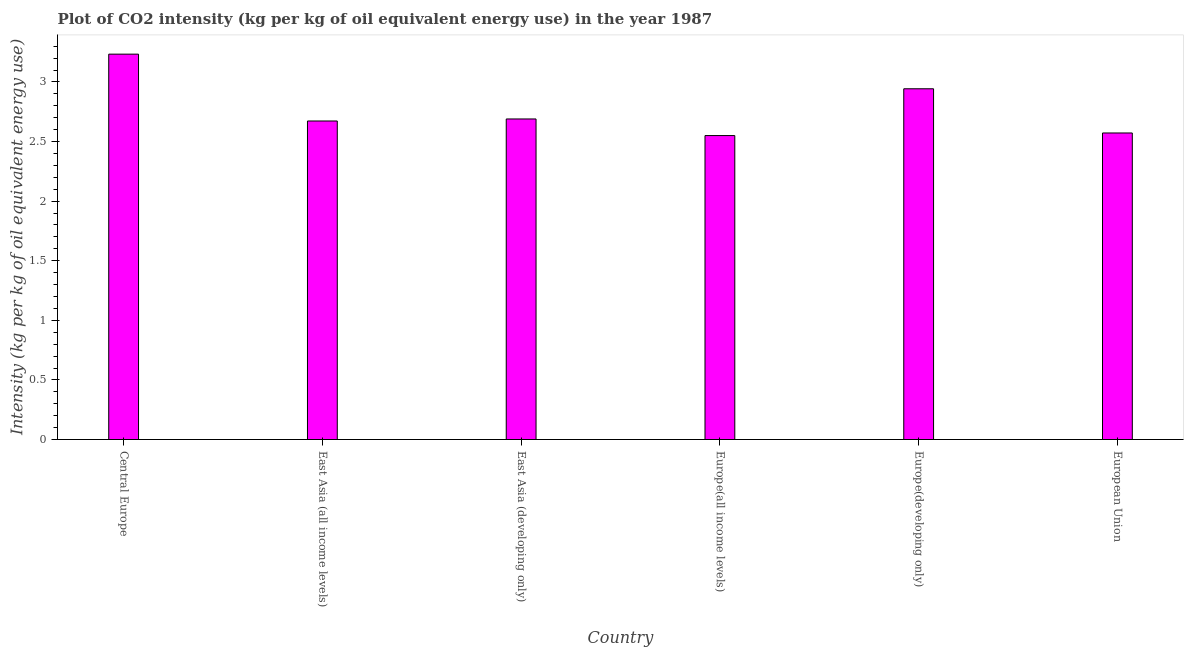Does the graph contain any zero values?
Keep it short and to the point. No. What is the title of the graph?
Offer a very short reply. Plot of CO2 intensity (kg per kg of oil equivalent energy use) in the year 1987. What is the label or title of the X-axis?
Your answer should be very brief. Country. What is the label or title of the Y-axis?
Provide a short and direct response. Intensity (kg per kg of oil equivalent energy use). What is the co2 intensity in East Asia (all income levels)?
Keep it short and to the point. 2.67. Across all countries, what is the maximum co2 intensity?
Make the answer very short. 3.23. Across all countries, what is the minimum co2 intensity?
Your answer should be very brief. 2.55. In which country was the co2 intensity maximum?
Offer a terse response. Central Europe. In which country was the co2 intensity minimum?
Your response must be concise. Europe(all income levels). What is the sum of the co2 intensity?
Provide a succinct answer. 16.66. What is the difference between the co2 intensity in East Asia (all income levels) and Europe(all income levels)?
Keep it short and to the point. 0.12. What is the average co2 intensity per country?
Provide a succinct answer. 2.78. What is the median co2 intensity?
Keep it short and to the point. 2.68. What is the ratio of the co2 intensity in Central Europe to that in Europe(developing only)?
Your response must be concise. 1.1. Is the co2 intensity in East Asia (all income levels) less than that in Europe(all income levels)?
Provide a short and direct response. No. Is the difference between the co2 intensity in East Asia (all income levels) and Europe(all income levels) greater than the difference between any two countries?
Keep it short and to the point. No. What is the difference between the highest and the second highest co2 intensity?
Offer a terse response. 0.29. Is the sum of the co2 intensity in Europe(developing only) and European Union greater than the maximum co2 intensity across all countries?
Your answer should be compact. Yes. What is the difference between the highest and the lowest co2 intensity?
Offer a very short reply. 0.68. What is the Intensity (kg per kg of oil equivalent energy use) of Central Europe?
Provide a short and direct response. 3.23. What is the Intensity (kg per kg of oil equivalent energy use) of East Asia (all income levels)?
Your answer should be very brief. 2.67. What is the Intensity (kg per kg of oil equivalent energy use) of East Asia (developing only)?
Offer a very short reply. 2.69. What is the Intensity (kg per kg of oil equivalent energy use) of Europe(all income levels)?
Provide a succinct answer. 2.55. What is the Intensity (kg per kg of oil equivalent energy use) in Europe(developing only)?
Provide a succinct answer. 2.94. What is the Intensity (kg per kg of oil equivalent energy use) in European Union?
Ensure brevity in your answer.  2.57. What is the difference between the Intensity (kg per kg of oil equivalent energy use) in Central Europe and East Asia (all income levels)?
Your answer should be very brief. 0.56. What is the difference between the Intensity (kg per kg of oil equivalent energy use) in Central Europe and East Asia (developing only)?
Your answer should be compact. 0.54. What is the difference between the Intensity (kg per kg of oil equivalent energy use) in Central Europe and Europe(all income levels)?
Offer a terse response. 0.68. What is the difference between the Intensity (kg per kg of oil equivalent energy use) in Central Europe and Europe(developing only)?
Offer a very short reply. 0.29. What is the difference between the Intensity (kg per kg of oil equivalent energy use) in Central Europe and European Union?
Give a very brief answer. 0.66. What is the difference between the Intensity (kg per kg of oil equivalent energy use) in East Asia (all income levels) and East Asia (developing only)?
Give a very brief answer. -0.02. What is the difference between the Intensity (kg per kg of oil equivalent energy use) in East Asia (all income levels) and Europe(all income levels)?
Ensure brevity in your answer.  0.12. What is the difference between the Intensity (kg per kg of oil equivalent energy use) in East Asia (all income levels) and Europe(developing only)?
Your answer should be compact. -0.27. What is the difference between the Intensity (kg per kg of oil equivalent energy use) in East Asia (all income levels) and European Union?
Offer a very short reply. 0.1. What is the difference between the Intensity (kg per kg of oil equivalent energy use) in East Asia (developing only) and Europe(all income levels)?
Provide a short and direct response. 0.14. What is the difference between the Intensity (kg per kg of oil equivalent energy use) in East Asia (developing only) and Europe(developing only)?
Give a very brief answer. -0.25. What is the difference between the Intensity (kg per kg of oil equivalent energy use) in East Asia (developing only) and European Union?
Your response must be concise. 0.12. What is the difference between the Intensity (kg per kg of oil equivalent energy use) in Europe(all income levels) and Europe(developing only)?
Make the answer very short. -0.39. What is the difference between the Intensity (kg per kg of oil equivalent energy use) in Europe(all income levels) and European Union?
Make the answer very short. -0.02. What is the difference between the Intensity (kg per kg of oil equivalent energy use) in Europe(developing only) and European Union?
Give a very brief answer. 0.37. What is the ratio of the Intensity (kg per kg of oil equivalent energy use) in Central Europe to that in East Asia (all income levels)?
Your answer should be compact. 1.21. What is the ratio of the Intensity (kg per kg of oil equivalent energy use) in Central Europe to that in East Asia (developing only)?
Keep it short and to the point. 1.2. What is the ratio of the Intensity (kg per kg of oil equivalent energy use) in Central Europe to that in Europe(all income levels)?
Your answer should be compact. 1.27. What is the ratio of the Intensity (kg per kg of oil equivalent energy use) in Central Europe to that in Europe(developing only)?
Your answer should be very brief. 1.1. What is the ratio of the Intensity (kg per kg of oil equivalent energy use) in Central Europe to that in European Union?
Your answer should be compact. 1.26. What is the ratio of the Intensity (kg per kg of oil equivalent energy use) in East Asia (all income levels) to that in East Asia (developing only)?
Your answer should be very brief. 0.99. What is the ratio of the Intensity (kg per kg of oil equivalent energy use) in East Asia (all income levels) to that in Europe(all income levels)?
Offer a very short reply. 1.05. What is the ratio of the Intensity (kg per kg of oil equivalent energy use) in East Asia (all income levels) to that in Europe(developing only)?
Provide a short and direct response. 0.91. What is the ratio of the Intensity (kg per kg of oil equivalent energy use) in East Asia (all income levels) to that in European Union?
Give a very brief answer. 1.04. What is the ratio of the Intensity (kg per kg of oil equivalent energy use) in East Asia (developing only) to that in Europe(all income levels)?
Provide a short and direct response. 1.05. What is the ratio of the Intensity (kg per kg of oil equivalent energy use) in East Asia (developing only) to that in Europe(developing only)?
Your answer should be compact. 0.91. What is the ratio of the Intensity (kg per kg of oil equivalent energy use) in East Asia (developing only) to that in European Union?
Your response must be concise. 1.05. What is the ratio of the Intensity (kg per kg of oil equivalent energy use) in Europe(all income levels) to that in Europe(developing only)?
Your answer should be compact. 0.87. What is the ratio of the Intensity (kg per kg of oil equivalent energy use) in Europe(all income levels) to that in European Union?
Your answer should be very brief. 0.99. What is the ratio of the Intensity (kg per kg of oil equivalent energy use) in Europe(developing only) to that in European Union?
Provide a short and direct response. 1.14. 